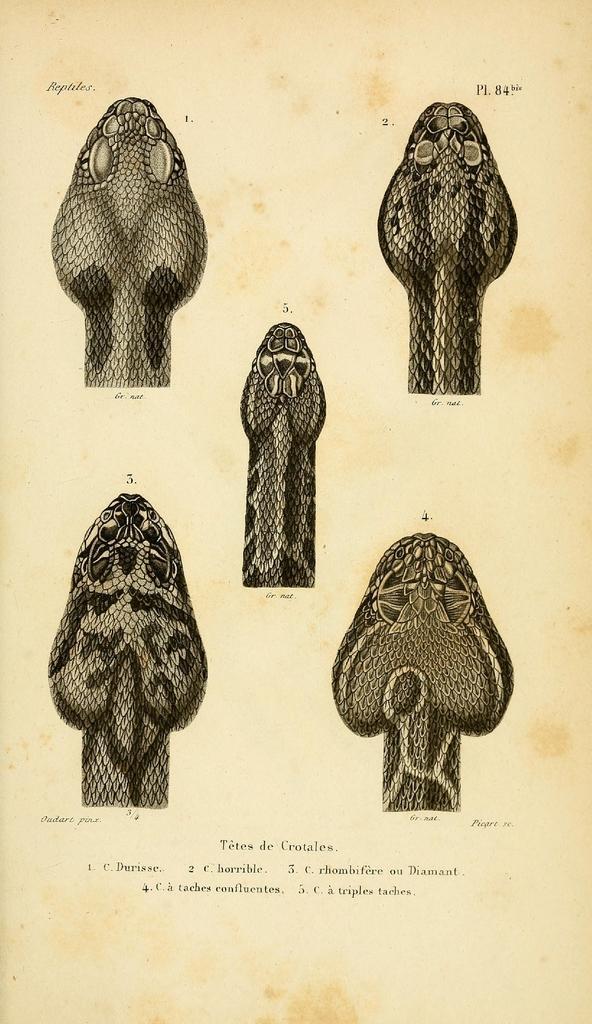In one or two sentences, can you explain what this image depicts? In this image, I can see the heads of the snakes, words and numbers on a paper. 